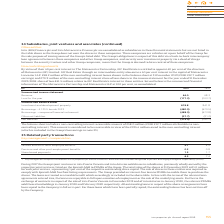According to Intu Properties's financial document, What does the key management comprise of? directors of intu properties plc and the Executive Committee who have been designated as persons discharging managerial responsibility (PDMR). The document states: "1 Key management comprises the directors of intu properties plc and the Executive Committee who have been designated as persons discharging managerial..." Also, What is the total value of shares at 31 December 2019 for each joint venture? According to the financial document, €1.0 million. The relevant text states: "e total value of the shares at 31 December 2019 is €1.0 million for each joint venture, representing 1 per cent of the respective outstanding share capital. The sal..." Also, What are the sale of shares in the entities required to comply with? Spanish MaB free float listing requirements. The document states: "res in these entities was required to comply with Spanish MaB free float listing requirements. The Group provided an interest-free loan to PDMRs to en..." Also, can you calculate: What is the percentage change in the salaries and short-term employee benefits from 2018 to 2019? To answer this question, I need to perform calculations using the financial data. The calculation is: (4.7-4.9)/4.9, which equals -4.08 (percentage). This is based on the information: "Salaries and short-term employee benefits 4.7 4.9 Salaries and short-term employee benefits 4.7 4.9..." The key data points involved are: 4.7, 4.9. Also, can you calculate: What is the percentage change in the Pensions and other post-employment benefits from 2018 to 2019? To answer this question, I need to perform calculations using the financial data. The calculation is: (0.3-0.8)/0.8, which equals -62.5 (percentage). This is based on the information: "Pensions and other post-employment benefits 0.3 0.8 Pensions and other post-employment benefits 0.3 0.8..." The key data points involved are: 0.3, 0.8. Additionally, In which year is there a higher share-based payment? According to the financial document, 2018. The relevant text states: "£m 2019 2018..." 